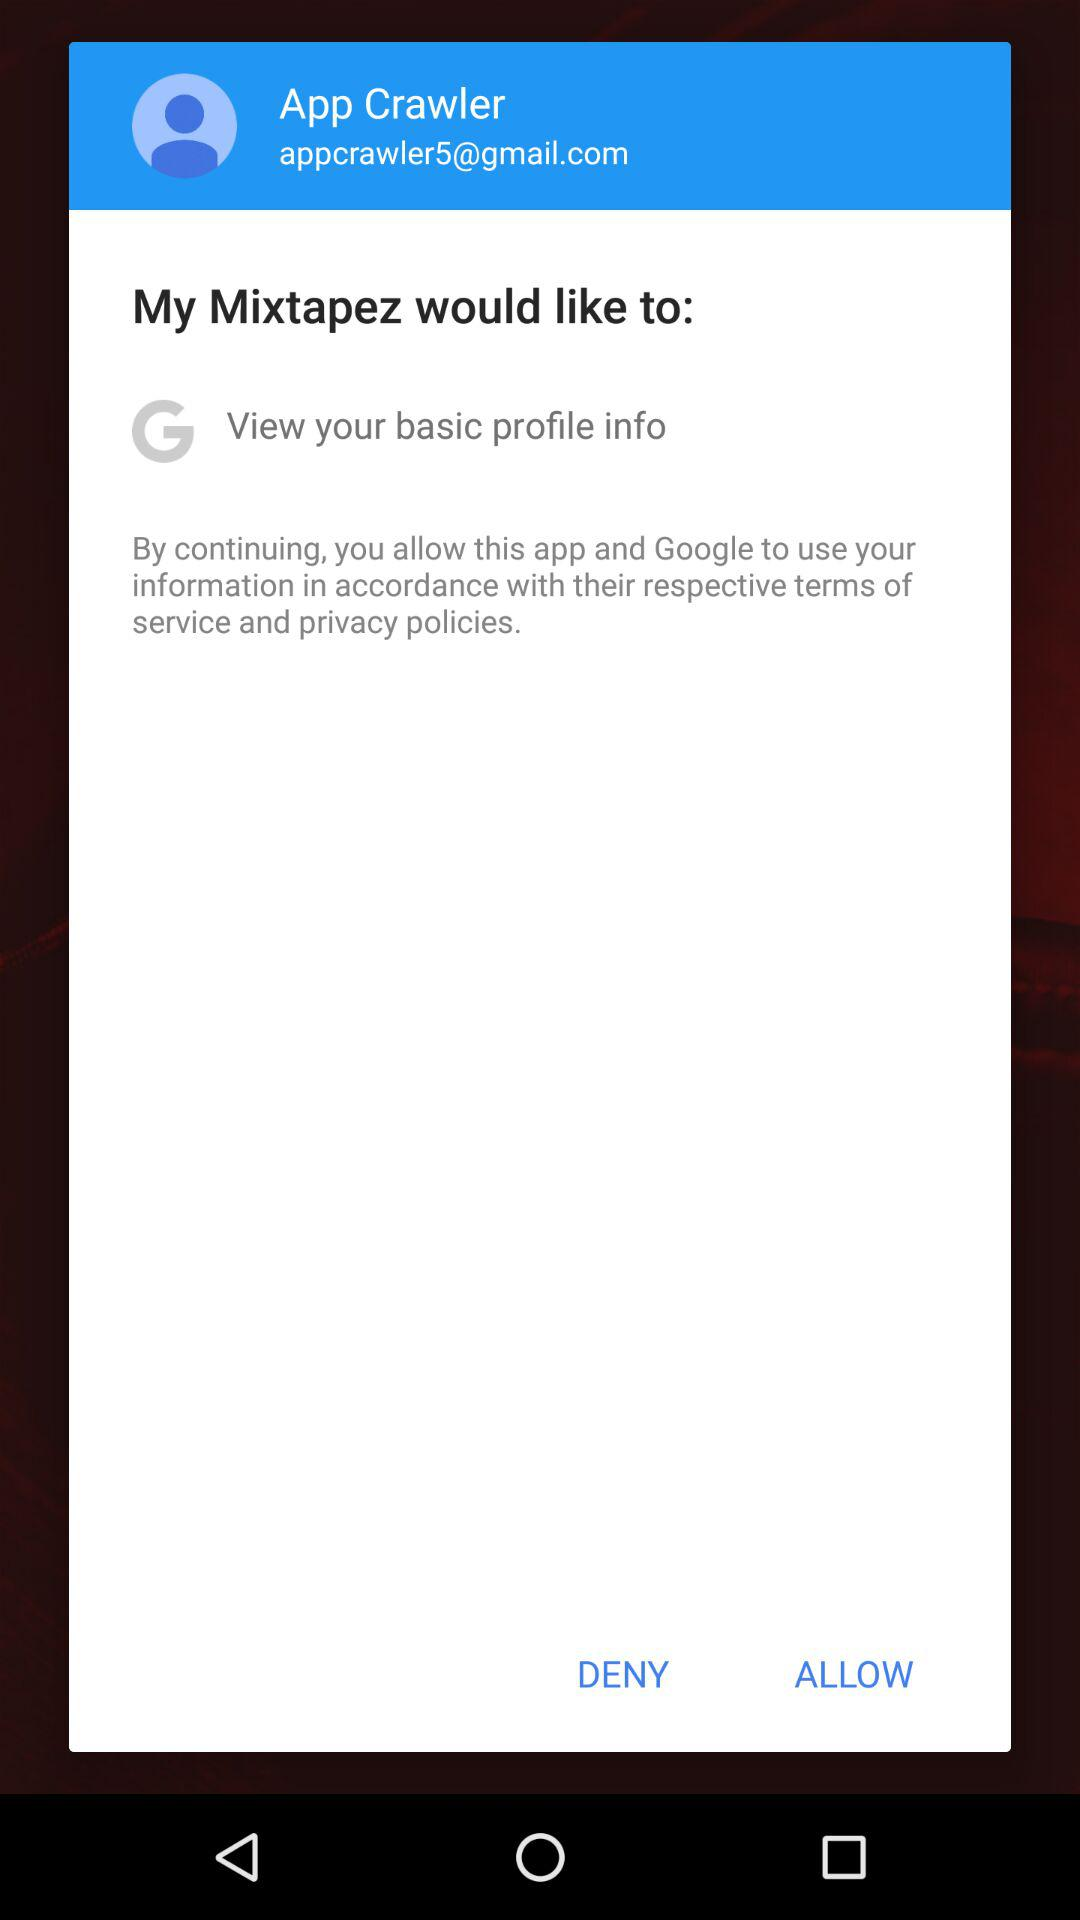What is the user name? The user name is App Crawler. 